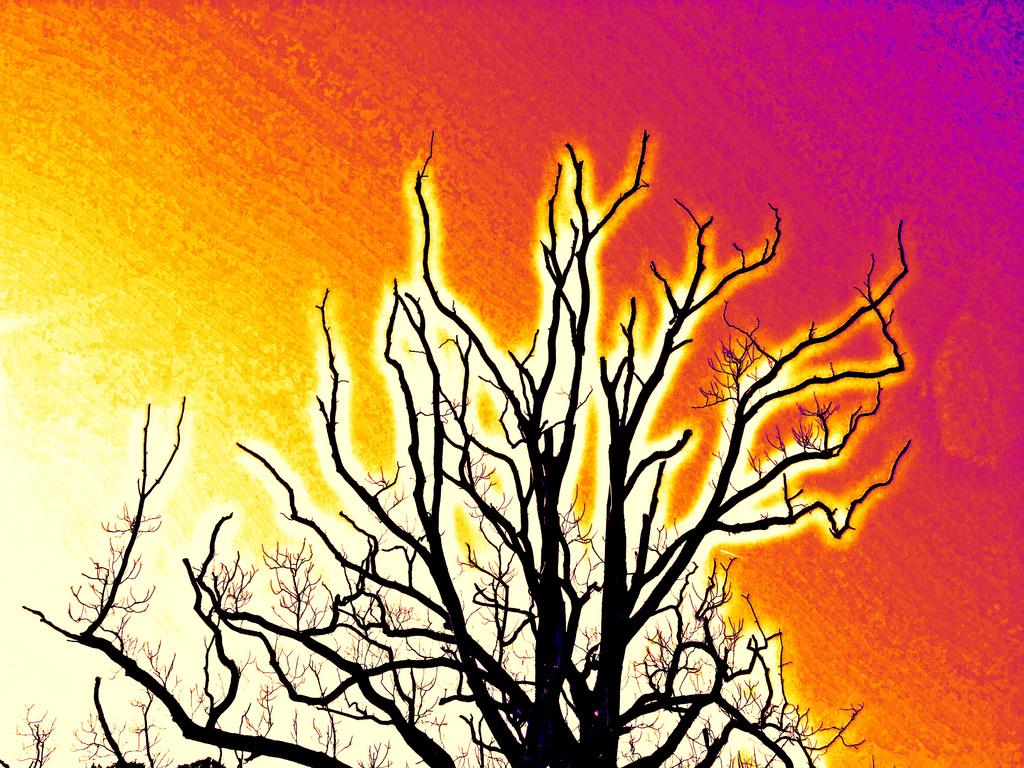What is the main subject of the image? The image contains a painting. What is depicted in the painting? The painting includes a dry tree. Can you describe the background of the painting? The painting has a colorful background. How many lizards can be seen climbing the dry tree in the painting? There are no lizards present in the painting; it only features a dry tree and a colorful background. 